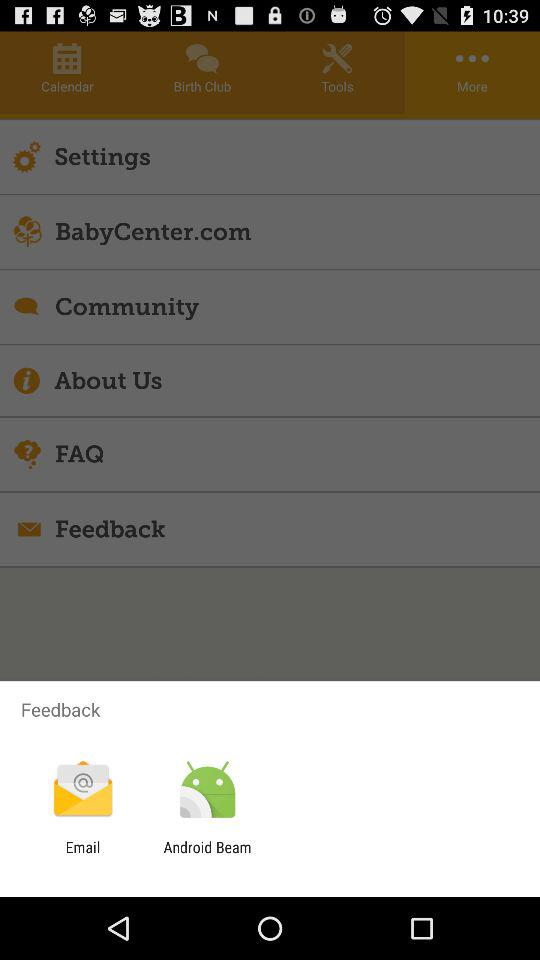Through which option can we share feedback? The options for sharing the feedback are "Email" and "Android Beam". 